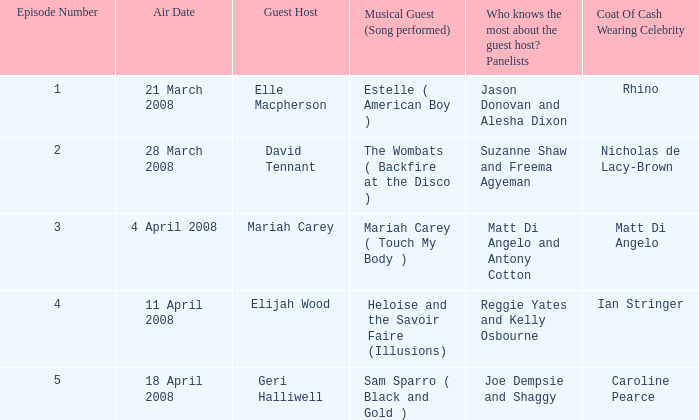Name the musical guest where guest host is elle macpherson Estelle ( American Boy ). 